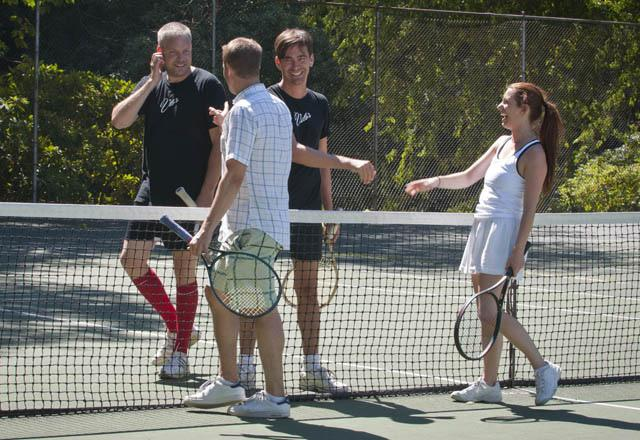How much farther can the red socks be pulled up normally?

Choices:
A) to calves
B) to head
C) not much
D) to stomach not much 